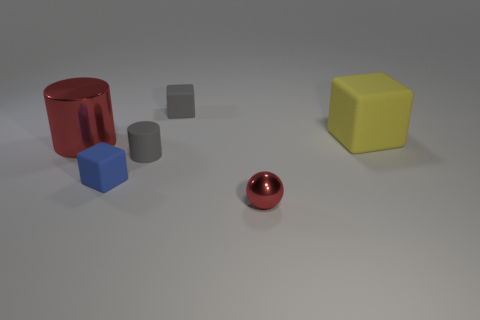Are there any other things that have the same shape as the tiny metallic thing?
Keep it short and to the point. No. Do the shiny thing to the right of the tiny gray rubber cube and the shiny cylinder have the same color?
Offer a terse response. Yes. What number of things are either red things that are behind the tiny blue matte cube or big blue matte things?
Your answer should be very brief. 1. Is the number of small red spheres that are in front of the blue block greater than the number of tiny red things that are in front of the red sphere?
Your answer should be compact. Yes. Does the yellow object have the same material as the small gray cube?
Your response must be concise. Yes. The tiny object that is both on the right side of the gray cylinder and behind the tiny shiny ball has what shape?
Provide a short and direct response. Cube. What shape is the big yellow thing that is the same material as the blue thing?
Offer a terse response. Cube. Are any big purple shiny balls visible?
Offer a very short reply. No. Are there any shiny objects on the left side of the red metal object behind the tiny red metal ball?
Provide a short and direct response. No. Is the number of blue blocks greater than the number of big yellow matte cylinders?
Offer a very short reply. Yes. 